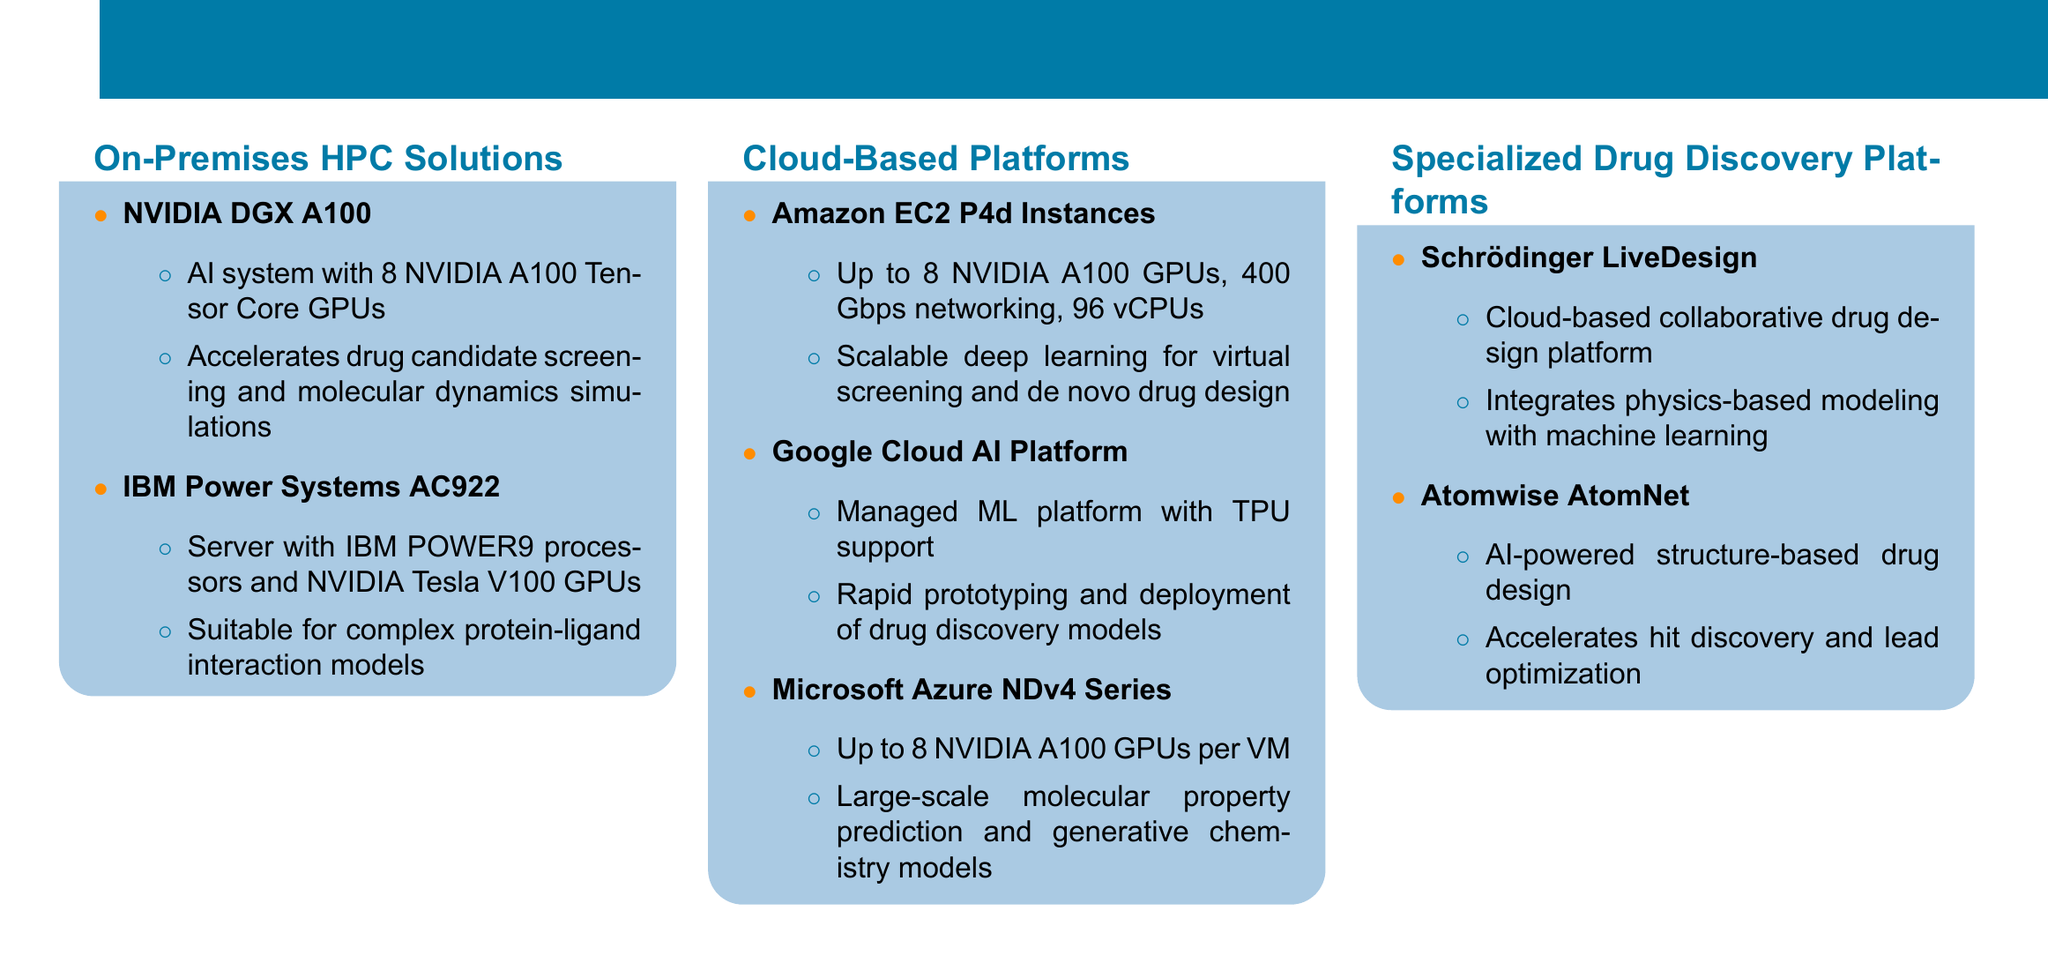What is the title of the document? The title is provided at the top of the document in a prominent format.
Answer: High-Performance Computing Resources for Neural Network-Based Drug Discovery How many NVIDIA A100 GPUs does the NVIDIA DGX A100 have? The information is listed under the specifications of the NVIDIA DGX A100 in the catalog.
Answer: 8 Which IBM system is mentioned for complex protein-ligand interaction models? The document lists specific systems under the On-Premises HPC Solutions section.
Answer: IBM Power Systems AC922 What is a feature of the Amazon EC2 P4d Instances? The document outlines the specifications and capabilities of Amazon EC2 P4d Instances.
Answer: 8 NVIDIA A100 GPUs What platform integrates physics-based modeling with machine learning? The question requires identifying a platform specifically focused on drug design mentioned in the document.
Answer: Schrödinger LiveDesign Which cloud platform supports TPU? This information can be found in the section detailing cloud-based platforms.
Answer: Google Cloud AI Platform How many Gbps networking capabilities does the Amazon EC2 P4d Instances have? The document mentions networking specifications in relation to the Amazon EC2 P4d Instances.
Answer: 400 Gbps What is the focus of Atomwise AtomNet? The document specifically describes the purpose and capabilities of Atomwise AtomNet.
Answer: AI-powered structure-based drug design 